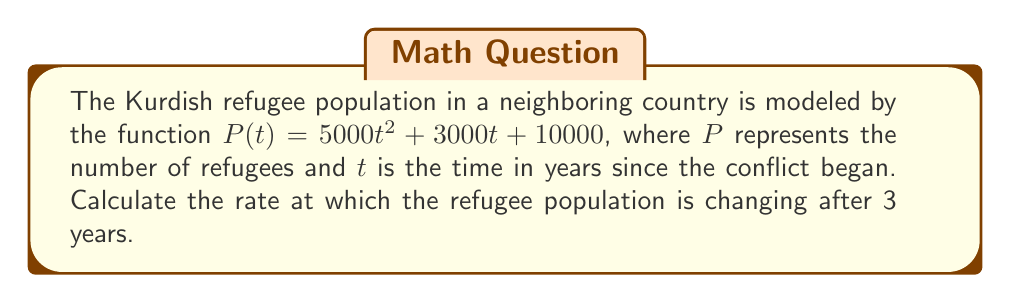Could you help me with this problem? To find the rate of change in the refugee population, we need to calculate the derivative of the given function and then evaluate it at $t = 3$.

1. Given function: $P(t) = 5000t^2 + 3000t + 10000$

2. Calculate the derivative:
   $$\frac{dP}{dt} = \frac{d}{dt}(5000t^2 + 3000t + 10000)$$
   $$\frac{dP}{dt} = 10000t + 3000$$

3. Evaluate the derivative at $t = 3$:
   $$\frac{dP}{dt}\bigg|_{t=3} = 10000(3) + 3000$$
   $$\frac{dP}{dt}\bigg|_{t=3} = 30000 + 3000 = 33000$$

The rate of change is 33,000 refugees per year after 3 years.
Answer: 33,000 refugees/year 